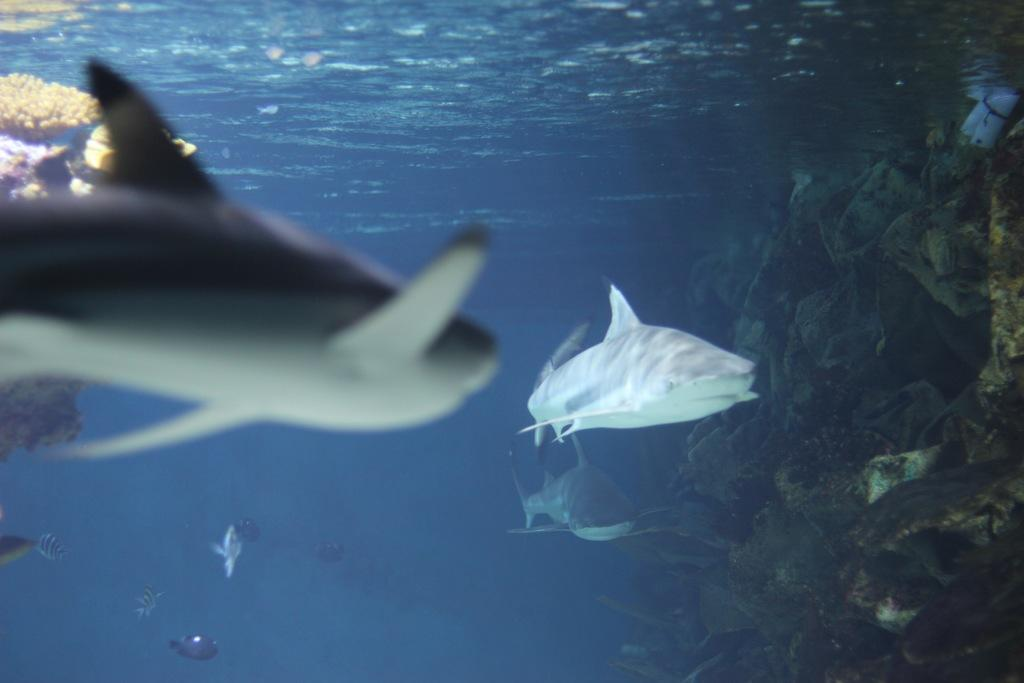What is the primary element in the image? There is water in the image. What type of animals can be seen in the water? There are fishes in the image. What type of card can be seen floating in the water? There is no card present in the image; it only features water and fishes. 